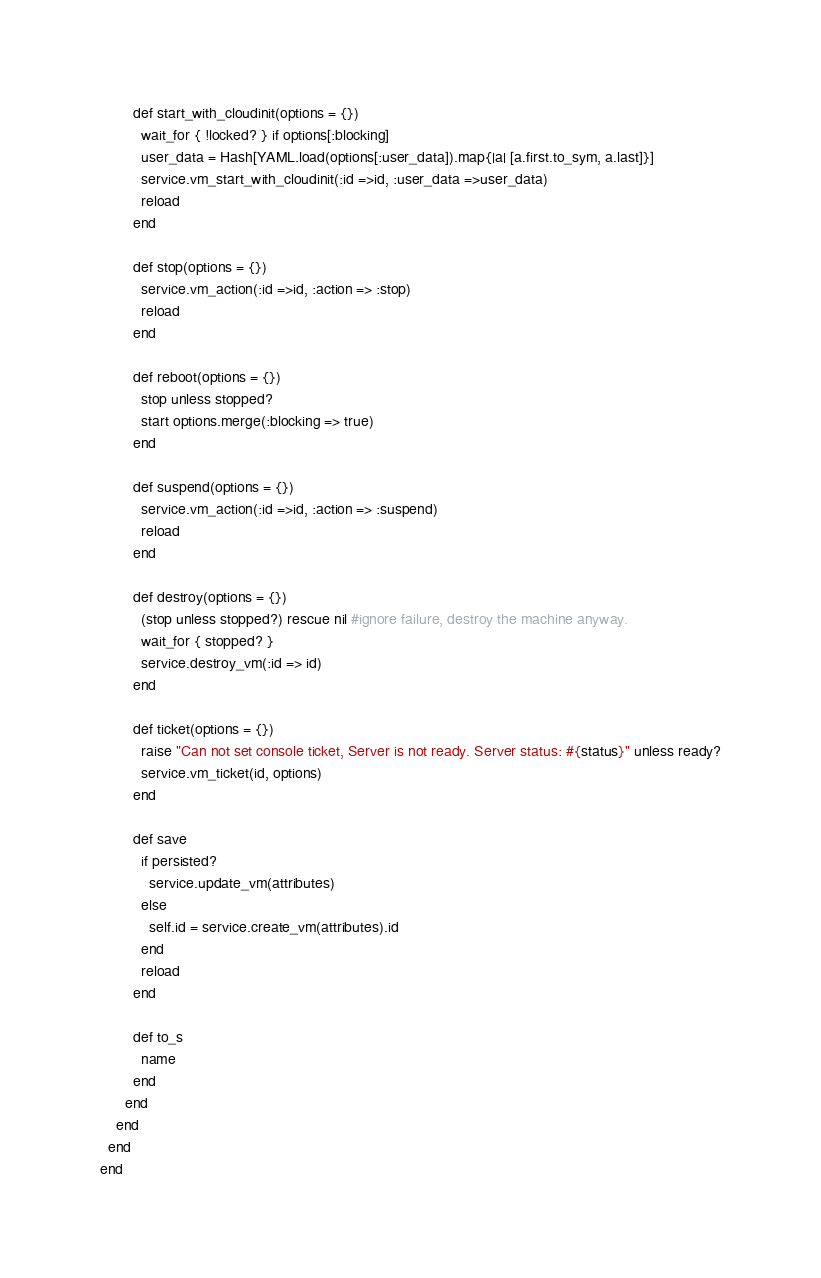<code> <loc_0><loc_0><loc_500><loc_500><_Ruby_>        def start_with_cloudinit(options = {})
          wait_for { !locked? } if options[:blocking]
          user_data = Hash[YAML.load(options[:user_data]).map{|a| [a.first.to_sym, a.last]}]
          service.vm_start_with_cloudinit(:id =>id, :user_data =>user_data)
          reload
        end

        def stop(options = {})
          service.vm_action(:id =>id, :action => :stop)
          reload
        end

        def reboot(options = {})
          stop unless stopped?
          start options.merge(:blocking => true)
        end

        def suspend(options = {})
          service.vm_action(:id =>id, :action => :suspend)
          reload
        end

        def destroy(options = {})
          (stop unless stopped?) rescue nil #ignore failure, destroy the machine anyway.
          wait_for { stopped? }
          service.destroy_vm(:id => id)
        end

        def ticket(options = {})
          raise "Can not set console ticket, Server is not ready. Server status: #{status}" unless ready?
          service.vm_ticket(id, options)
        end

        def save
          if persisted?
            service.update_vm(attributes)
          else
            self.id = service.create_vm(attributes).id
          end
          reload
        end

        def to_s
          name
        end
      end
    end
  end
end
</code> 